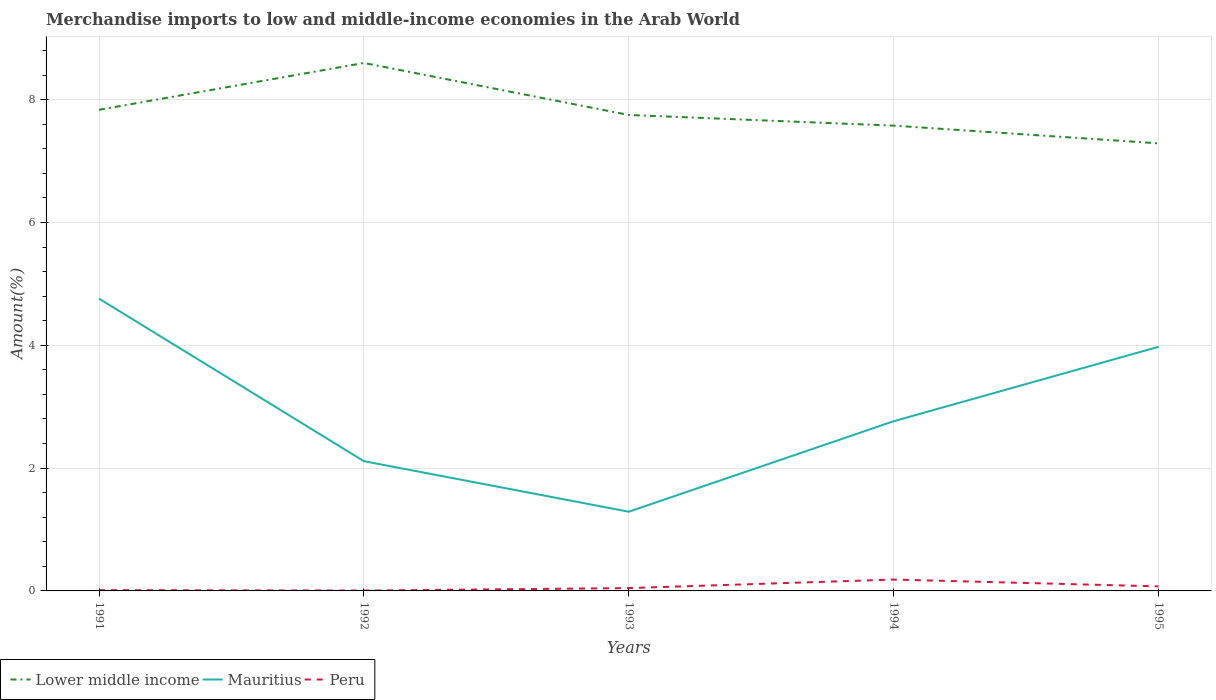How many different coloured lines are there?
Keep it short and to the point. 3. Does the line corresponding to Lower middle income intersect with the line corresponding to Mauritius?
Offer a terse response. No. Is the number of lines equal to the number of legend labels?
Offer a terse response. Yes. Across all years, what is the maximum percentage of amount earned from merchandise imports in Mauritius?
Provide a succinct answer. 1.29. In which year was the percentage of amount earned from merchandise imports in Mauritius maximum?
Offer a very short reply. 1993. What is the total percentage of amount earned from merchandise imports in Lower middle income in the graph?
Provide a succinct answer. 0.17. What is the difference between the highest and the second highest percentage of amount earned from merchandise imports in Peru?
Keep it short and to the point. 0.18. Is the percentage of amount earned from merchandise imports in Peru strictly greater than the percentage of amount earned from merchandise imports in Mauritius over the years?
Provide a succinct answer. Yes. How many lines are there?
Your answer should be very brief. 3. How many years are there in the graph?
Keep it short and to the point. 5. Are the values on the major ticks of Y-axis written in scientific E-notation?
Offer a very short reply. No. Does the graph contain any zero values?
Make the answer very short. No. Does the graph contain grids?
Ensure brevity in your answer.  Yes. Where does the legend appear in the graph?
Offer a very short reply. Bottom left. How are the legend labels stacked?
Your answer should be compact. Horizontal. What is the title of the graph?
Provide a succinct answer. Merchandise imports to low and middle-income economies in the Arab World. Does "Uruguay" appear as one of the legend labels in the graph?
Make the answer very short. No. What is the label or title of the Y-axis?
Offer a very short reply. Amount(%). What is the Amount(%) of Lower middle income in 1991?
Keep it short and to the point. 7.83. What is the Amount(%) in Mauritius in 1991?
Your response must be concise. 4.76. What is the Amount(%) in Peru in 1991?
Offer a terse response. 0.01. What is the Amount(%) of Lower middle income in 1992?
Offer a very short reply. 8.6. What is the Amount(%) of Mauritius in 1992?
Provide a short and direct response. 2.11. What is the Amount(%) of Peru in 1992?
Ensure brevity in your answer.  0.01. What is the Amount(%) of Lower middle income in 1993?
Ensure brevity in your answer.  7.75. What is the Amount(%) in Mauritius in 1993?
Provide a succinct answer. 1.29. What is the Amount(%) in Peru in 1993?
Provide a succinct answer. 0.05. What is the Amount(%) of Lower middle income in 1994?
Provide a short and direct response. 7.58. What is the Amount(%) in Mauritius in 1994?
Your answer should be very brief. 2.76. What is the Amount(%) in Peru in 1994?
Your answer should be very brief. 0.18. What is the Amount(%) of Lower middle income in 1995?
Keep it short and to the point. 7.29. What is the Amount(%) of Mauritius in 1995?
Provide a succinct answer. 3.98. What is the Amount(%) in Peru in 1995?
Your answer should be compact. 0.07. Across all years, what is the maximum Amount(%) of Lower middle income?
Keep it short and to the point. 8.6. Across all years, what is the maximum Amount(%) in Mauritius?
Keep it short and to the point. 4.76. Across all years, what is the maximum Amount(%) in Peru?
Provide a succinct answer. 0.18. Across all years, what is the minimum Amount(%) of Lower middle income?
Your answer should be very brief. 7.29. Across all years, what is the minimum Amount(%) of Mauritius?
Offer a very short reply. 1.29. Across all years, what is the minimum Amount(%) in Peru?
Your answer should be compact. 0.01. What is the total Amount(%) of Lower middle income in the graph?
Your answer should be compact. 39.05. What is the total Amount(%) of Mauritius in the graph?
Make the answer very short. 14.9. What is the total Amount(%) in Peru in the graph?
Your response must be concise. 0.32. What is the difference between the Amount(%) in Lower middle income in 1991 and that in 1992?
Make the answer very short. -0.76. What is the difference between the Amount(%) of Mauritius in 1991 and that in 1992?
Give a very brief answer. 2.65. What is the difference between the Amount(%) in Peru in 1991 and that in 1992?
Your response must be concise. 0.01. What is the difference between the Amount(%) in Lower middle income in 1991 and that in 1993?
Your response must be concise. 0.08. What is the difference between the Amount(%) of Mauritius in 1991 and that in 1993?
Your response must be concise. 3.47. What is the difference between the Amount(%) in Peru in 1991 and that in 1993?
Provide a short and direct response. -0.03. What is the difference between the Amount(%) in Lower middle income in 1991 and that in 1994?
Provide a succinct answer. 0.26. What is the difference between the Amount(%) of Mauritius in 1991 and that in 1994?
Keep it short and to the point. 2. What is the difference between the Amount(%) in Peru in 1991 and that in 1994?
Your answer should be very brief. -0.17. What is the difference between the Amount(%) of Lower middle income in 1991 and that in 1995?
Ensure brevity in your answer.  0.55. What is the difference between the Amount(%) in Mauritius in 1991 and that in 1995?
Your answer should be very brief. 0.78. What is the difference between the Amount(%) of Peru in 1991 and that in 1995?
Make the answer very short. -0.06. What is the difference between the Amount(%) of Lower middle income in 1992 and that in 1993?
Give a very brief answer. 0.85. What is the difference between the Amount(%) of Mauritius in 1992 and that in 1993?
Offer a very short reply. 0.82. What is the difference between the Amount(%) in Peru in 1992 and that in 1993?
Give a very brief answer. -0.04. What is the difference between the Amount(%) in Lower middle income in 1992 and that in 1994?
Your answer should be compact. 1.02. What is the difference between the Amount(%) in Mauritius in 1992 and that in 1994?
Make the answer very short. -0.65. What is the difference between the Amount(%) in Peru in 1992 and that in 1994?
Provide a succinct answer. -0.18. What is the difference between the Amount(%) in Lower middle income in 1992 and that in 1995?
Ensure brevity in your answer.  1.31. What is the difference between the Amount(%) in Mauritius in 1992 and that in 1995?
Keep it short and to the point. -1.86. What is the difference between the Amount(%) of Peru in 1992 and that in 1995?
Give a very brief answer. -0.07. What is the difference between the Amount(%) of Lower middle income in 1993 and that in 1994?
Your answer should be very brief. 0.17. What is the difference between the Amount(%) of Mauritius in 1993 and that in 1994?
Your answer should be compact. -1.47. What is the difference between the Amount(%) in Peru in 1993 and that in 1994?
Offer a terse response. -0.14. What is the difference between the Amount(%) in Lower middle income in 1993 and that in 1995?
Make the answer very short. 0.46. What is the difference between the Amount(%) of Mauritius in 1993 and that in 1995?
Provide a succinct answer. -2.69. What is the difference between the Amount(%) of Peru in 1993 and that in 1995?
Your answer should be very brief. -0.03. What is the difference between the Amount(%) of Lower middle income in 1994 and that in 1995?
Offer a very short reply. 0.29. What is the difference between the Amount(%) of Mauritius in 1994 and that in 1995?
Offer a terse response. -1.21. What is the difference between the Amount(%) in Peru in 1994 and that in 1995?
Your response must be concise. 0.11. What is the difference between the Amount(%) of Lower middle income in 1991 and the Amount(%) of Mauritius in 1992?
Offer a terse response. 5.72. What is the difference between the Amount(%) in Lower middle income in 1991 and the Amount(%) in Peru in 1992?
Offer a very short reply. 7.83. What is the difference between the Amount(%) of Mauritius in 1991 and the Amount(%) of Peru in 1992?
Your answer should be compact. 4.75. What is the difference between the Amount(%) of Lower middle income in 1991 and the Amount(%) of Mauritius in 1993?
Give a very brief answer. 6.54. What is the difference between the Amount(%) of Lower middle income in 1991 and the Amount(%) of Peru in 1993?
Keep it short and to the point. 7.79. What is the difference between the Amount(%) of Mauritius in 1991 and the Amount(%) of Peru in 1993?
Give a very brief answer. 4.71. What is the difference between the Amount(%) in Lower middle income in 1991 and the Amount(%) in Mauritius in 1994?
Offer a terse response. 5.07. What is the difference between the Amount(%) of Lower middle income in 1991 and the Amount(%) of Peru in 1994?
Give a very brief answer. 7.65. What is the difference between the Amount(%) in Mauritius in 1991 and the Amount(%) in Peru in 1994?
Make the answer very short. 4.58. What is the difference between the Amount(%) of Lower middle income in 1991 and the Amount(%) of Mauritius in 1995?
Offer a terse response. 3.86. What is the difference between the Amount(%) of Lower middle income in 1991 and the Amount(%) of Peru in 1995?
Make the answer very short. 7.76. What is the difference between the Amount(%) of Mauritius in 1991 and the Amount(%) of Peru in 1995?
Your response must be concise. 4.69. What is the difference between the Amount(%) in Lower middle income in 1992 and the Amount(%) in Mauritius in 1993?
Offer a very short reply. 7.31. What is the difference between the Amount(%) in Lower middle income in 1992 and the Amount(%) in Peru in 1993?
Make the answer very short. 8.55. What is the difference between the Amount(%) in Mauritius in 1992 and the Amount(%) in Peru in 1993?
Your response must be concise. 2.07. What is the difference between the Amount(%) of Lower middle income in 1992 and the Amount(%) of Mauritius in 1994?
Provide a succinct answer. 5.83. What is the difference between the Amount(%) in Lower middle income in 1992 and the Amount(%) in Peru in 1994?
Your response must be concise. 8.41. What is the difference between the Amount(%) in Mauritius in 1992 and the Amount(%) in Peru in 1994?
Make the answer very short. 1.93. What is the difference between the Amount(%) in Lower middle income in 1992 and the Amount(%) in Mauritius in 1995?
Offer a very short reply. 4.62. What is the difference between the Amount(%) in Lower middle income in 1992 and the Amount(%) in Peru in 1995?
Offer a terse response. 8.52. What is the difference between the Amount(%) in Mauritius in 1992 and the Amount(%) in Peru in 1995?
Provide a short and direct response. 2.04. What is the difference between the Amount(%) in Lower middle income in 1993 and the Amount(%) in Mauritius in 1994?
Your answer should be compact. 4.99. What is the difference between the Amount(%) in Lower middle income in 1993 and the Amount(%) in Peru in 1994?
Give a very brief answer. 7.57. What is the difference between the Amount(%) of Mauritius in 1993 and the Amount(%) of Peru in 1994?
Keep it short and to the point. 1.1. What is the difference between the Amount(%) in Lower middle income in 1993 and the Amount(%) in Mauritius in 1995?
Your answer should be very brief. 3.78. What is the difference between the Amount(%) in Lower middle income in 1993 and the Amount(%) in Peru in 1995?
Provide a succinct answer. 7.68. What is the difference between the Amount(%) of Mauritius in 1993 and the Amount(%) of Peru in 1995?
Make the answer very short. 1.22. What is the difference between the Amount(%) in Lower middle income in 1994 and the Amount(%) in Mauritius in 1995?
Offer a very short reply. 3.6. What is the difference between the Amount(%) in Lower middle income in 1994 and the Amount(%) in Peru in 1995?
Your answer should be compact. 7.5. What is the difference between the Amount(%) of Mauritius in 1994 and the Amount(%) of Peru in 1995?
Your response must be concise. 2.69. What is the average Amount(%) of Lower middle income per year?
Your answer should be compact. 7.81. What is the average Amount(%) in Mauritius per year?
Offer a terse response. 2.98. What is the average Amount(%) of Peru per year?
Provide a short and direct response. 0.06. In the year 1991, what is the difference between the Amount(%) of Lower middle income and Amount(%) of Mauritius?
Your answer should be very brief. 3.07. In the year 1991, what is the difference between the Amount(%) of Lower middle income and Amount(%) of Peru?
Provide a succinct answer. 7.82. In the year 1991, what is the difference between the Amount(%) in Mauritius and Amount(%) in Peru?
Offer a very short reply. 4.75. In the year 1992, what is the difference between the Amount(%) of Lower middle income and Amount(%) of Mauritius?
Offer a terse response. 6.48. In the year 1992, what is the difference between the Amount(%) in Lower middle income and Amount(%) in Peru?
Offer a very short reply. 8.59. In the year 1992, what is the difference between the Amount(%) in Mauritius and Amount(%) in Peru?
Ensure brevity in your answer.  2.11. In the year 1993, what is the difference between the Amount(%) in Lower middle income and Amount(%) in Mauritius?
Ensure brevity in your answer.  6.46. In the year 1993, what is the difference between the Amount(%) of Lower middle income and Amount(%) of Peru?
Give a very brief answer. 7.7. In the year 1993, what is the difference between the Amount(%) of Mauritius and Amount(%) of Peru?
Ensure brevity in your answer.  1.24. In the year 1994, what is the difference between the Amount(%) in Lower middle income and Amount(%) in Mauritius?
Offer a very short reply. 4.81. In the year 1994, what is the difference between the Amount(%) in Lower middle income and Amount(%) in Peru?
Ensure brevity in your answer.  7.39. In the year 1994, what is the difference between the Amount(%) in Mauritius and Amount(%) in Peru?
Ensure brevity in your answer.  2.58. In the year 1995, what is the difference between the Amount(%) in Lower middle income and Amount(%) in Mauritius?
Offer a terse response. 3.31. In the year 1995, what is the difference between the Amount(%) of Lower middle income and Amount(%) of Peru?
Give a very brief answer. 7.21. In the year 1995, what is the difference between the Amount(%) of Mauritius and Amount(%) of Peru?
Make the answer very short. 3.9. What is the ratio of the Amount(%) of Lower middle income in 1991 to that in 1992?
Keep it short and to the point. 0.91. What is the ratio of the Amount(%) of Mauritius in 1991 to that in 1992?
Your answer should be compact. 2.25. What is the ratio of the Amount(%) in Peru in 1991 to that in 1992?
Provide a succinct answer. 2.19. What is the ratio of the Amount(%) in Lower middle income in 1991 to that in 1993?
Your answer should be compact. 1.01. What is the ratio of the Amount(%) in Mauritius in 1991 to that in 1993?
Ensure brevity in your answer.  3.69. What is the ratio of the Amount(%) of Peru in 1991 to that in 1993?
Offer a very short reply. 0.28. What is the ratio of the Amount(%) in Lower middle income in 1991 to that in 1994?
Ensure brevity in your answer.  1.03. What is the ratio of the Amount(%) of Mauritius in 1991 to that in 1994?
Make the answer very short. 1.72. What is the ratio of the Amount(%) of Peru in 1991 to that in 1994?
Offer a terse response. 0.07. What is the ratio of the Amount(%) in Lower middle income in 1991 to that in 1995?
Offer a very short reply. 1.07. What is the ratio of the Amount(%) of Mauritius in 1991 to that in 1995?
Your answer should be compact. 1.2. What is the ratio of the Amount(%) of Peru in 1991 to that in 1995?
Offer a very short reply. 0.17. What is the ratio of the Amount(%) in Lower middle income in 1992 to that in 1993?
Your response must be concise. 1.11. What is the ratio of the Amount(%) of Mauritius in 1992 to that in 1993?
Ensure brevity in your answer.  1.64. What is the ratio of the Amount(%) of Peru in 1992 to that in 1993?
Keep it short and to the point. 0.13. What is the ratio of the Amount(%) of Lower middle income in 1992 to that in 1994?
Your answer should be very brief. 1.13. What is the ratio of the Amount(%) of Mauritius in 1992 to that in 1994?
Make the answer very short. 0.76. What is the ratio of the Amount(%) in Peru in 1992 to that in 1994?
Ensure brevity in your answer.  0.03. What is the ratio of the Amount(%) of Lower middle income in 1992 to that in 1995?
Your answer should be compact. 1.18. What is the ratio of the Amount(%) of Mauritius in 1992 to that in 1995?
Provide a succinct answer. 0.53. What is the ratio of the Amount(%) of Peru in 1992 to that in 1995?
Your answer should be very brief. 0.08. What is the ratio of the Amount(%) in Mauritius in 1993 to that in 1994?
Make the answer very short. 0.47. What is the ratio of the Amount(%) of Peru in 1993 to that in 1994?
Keep it short and to the point. 0.25. What is the ratio of the Amount(%) of Lower middle income in 1993 to that in 1995?
Ensure brevity in your answer.  1.06. What is the ratio of the Amount(%) of Mauritius in 1993 to that in 1995?
Your answer should be very brief. 0.32. What is the ratio of the Amount(%) in Peru in 1993 to that in 1995?
Provide a succinct answer. 0.62. What is the ratio of the Amount(%) of Lower middle income in 1994 to that in 1995?
Give a very brief answer. 1.04. What is the ratio of the Amount(%) in Mauritius in 1994 to that in 1995?
Your answer should be compact. 0.7. What is the ratio of the Amount(%) of Peru in 1994 to that in 1995?
Your answer should be compact. 2.5. What is the difference between the highest and the second highest Amount(%) of Lower middle income?
Ensure brevity in your answer.  0.76. What is the difference between the highest and the second highest Amount(%) in Mauritius?
Ensure brevity in your answer.  0.78. What is the difference between the highest and the second highest Amount(%) in Peru?
Make the answer very short. 0.11. What is the difference between the highest and the lowest Amount(%) of Lower middle income?
Make the answer very short. 1.31. What is the difference between the highest and the lowest Amount(%) in Mauritius?
Your response must be concise. 3.47. What is the difference between the highest and the lowest Amount(%) in Peru?
Give a very brief answer. 0.18. 